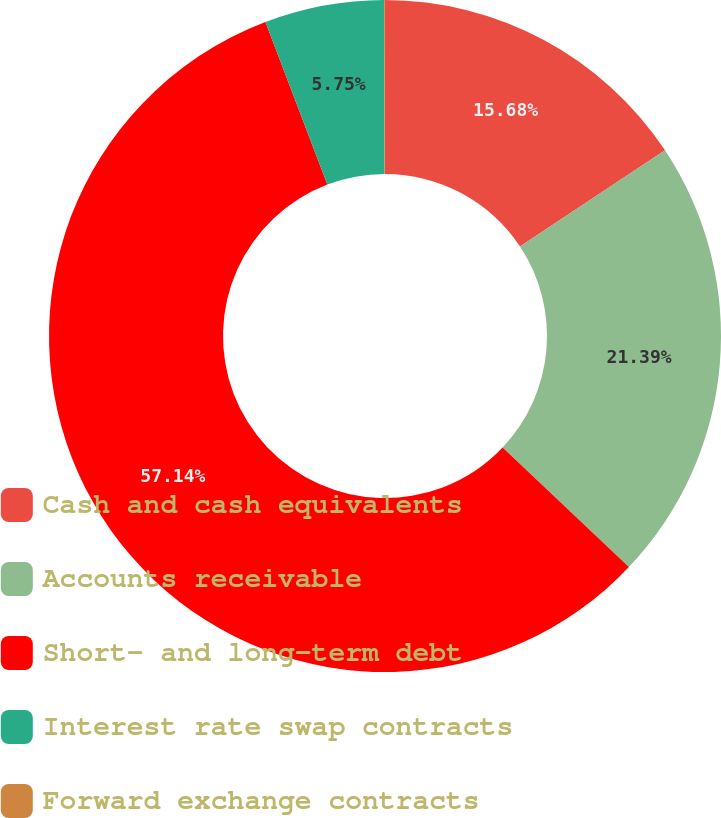Convert chart to OTSL. <chart><loc_0><loc_0><loc_500><loc_500><pie_chart><fcel>Cash and cash equivalents<fcel>Accounts receivable<fcel>Short- and long-term debt<fcel>Interest rate swap contracts<fcel>Forward exchange contracts<nl><fcel>15.68%<fcel>21.39%<fcel>57.14%<fcel>5.75%<fcel>0.04%<nl></chart> 